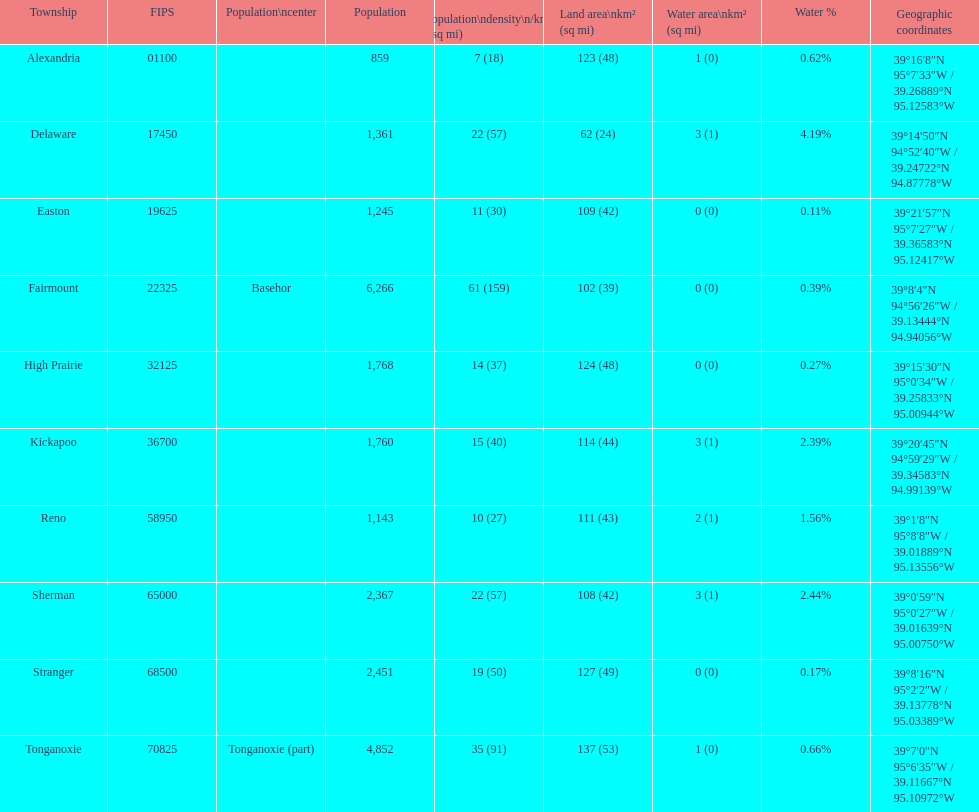Which township boasts the highest population? Fairmount. 